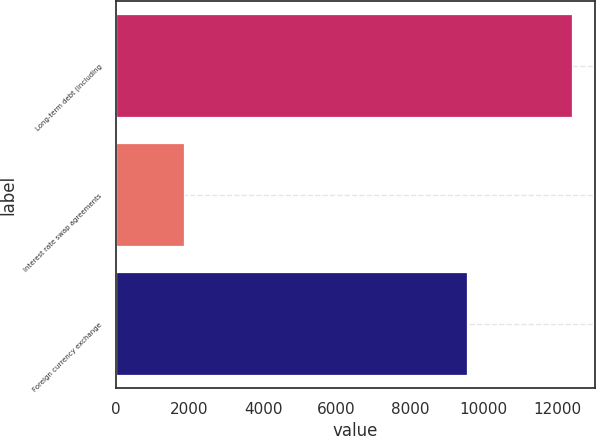<chart> <loc_0><loc_0><loc_500><loc_500><bar_chart><fcel>Long-term debt (including<fcel>Interest rate swap agreements<fcel>Foreign currency exchange<nl><fcel>12409<fcel>1850<fcel>9554<nl></chart> 